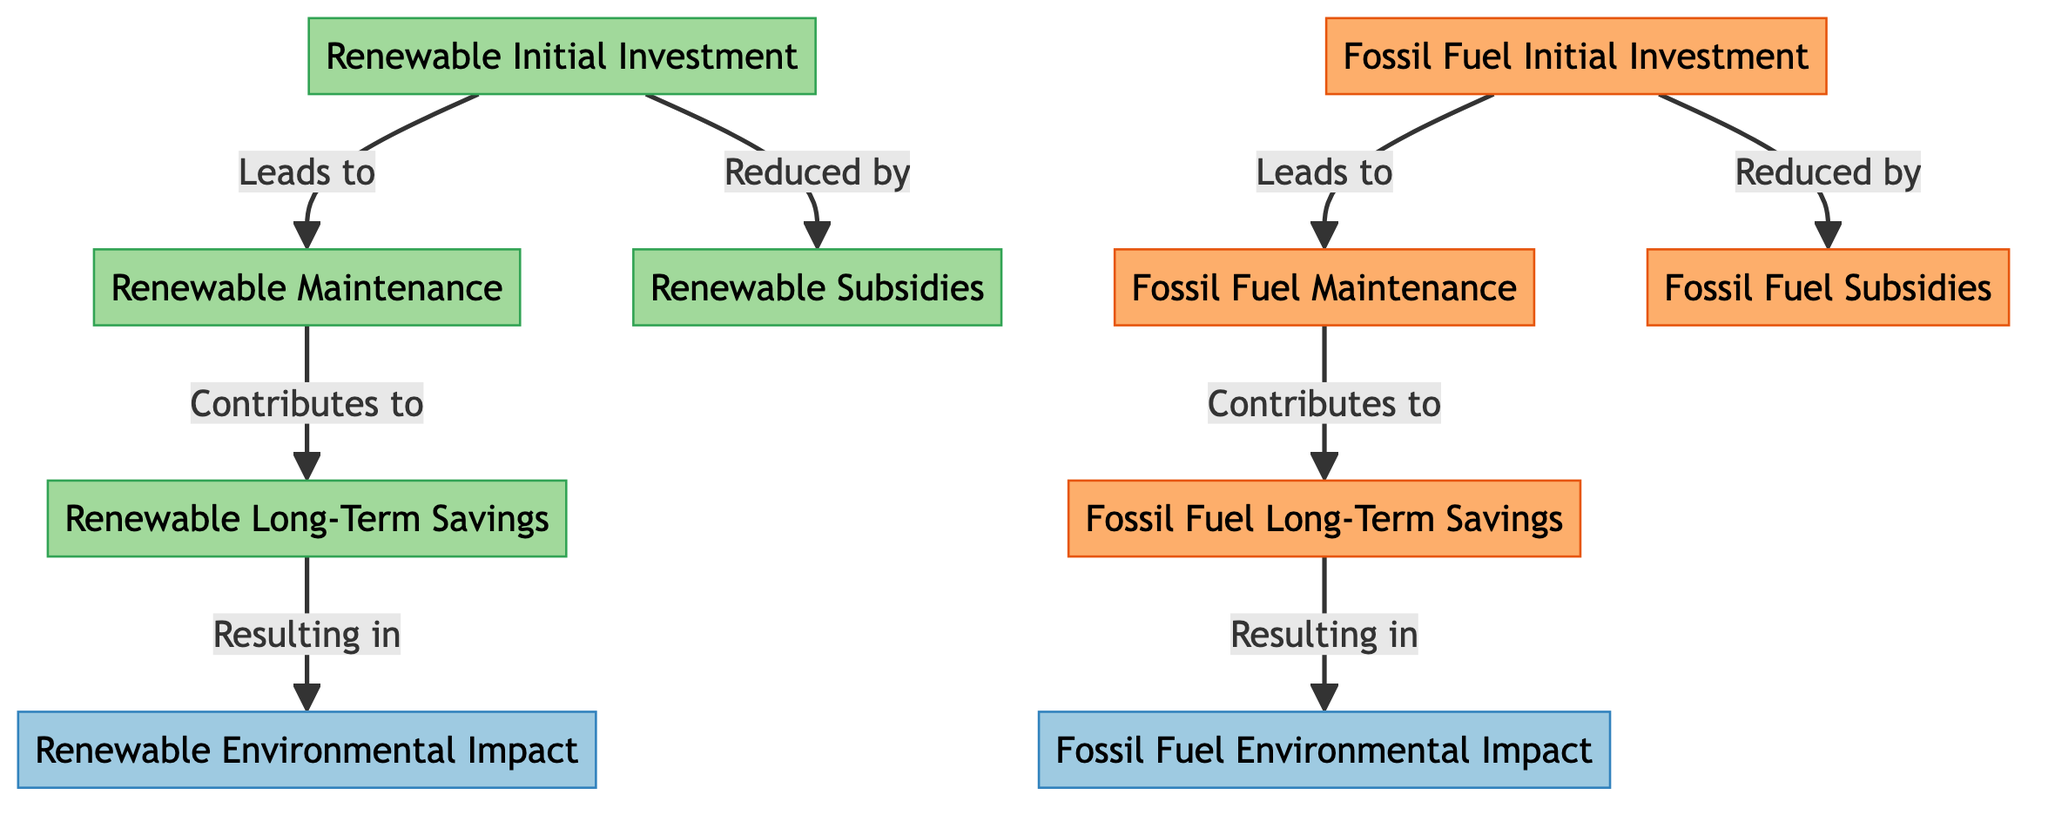What is the flow direction from Renewable Initial Investment? The arrow diverges from the Renewable Initial Investment node leading to both Renewable Maintenance and Renewable Subsidies nodes. This indicates that the initial investment impacts both the maintenance costs and potential subsidies received.
Answer: Renewable Maintenance, Renewable Subsidies How many nodes represent fossil fuel elements in the diagram? There are four nodes that specifically represent fossil fuel elements: Fossil Fuel Initial Investment, Fossil Fuel Maintenance, Fossil Fuel Long-Term Savings, and Fossil Fuel Subsidies.
Answer: Four What is the result of Renewable Long-Term Savings? Renewable Long-Term Savings leads to the Renewable Environmental Impact node, indicating that savings contribute to a positive environmental outcome.
Answer: Renewable Environmental Impact Which node is connected to both Fossil Fuel Initial Investment and Fossil Fuel Maintenance? The diagram indicates a direct connection where Fossil Fuel Initial Investment leads to Fossil Fuel Maintenance, showing the dependency between these two aspects.
Answer: Fossil Fuel Maintenance How do Renewable Subsidies affect Renewable Initial Investment? Renewable Subsidies are directly connected to the Renewable Initial Investment node with an arrow indicating they reduce the initial investment costs, highlighting their importance as financial support.
Answer: Reduced by What is the relationship between Fossil Fuel Long-Term Savings and Fossil Fuel Environmental Impact? Fossil Fuel Long-Term Savings leads into the Fossil Fuel Environmental Impact node, suggesting that the long-term financial benefits contribute to the environmental consequences of fossil fuels.
Answer: Resulting in What type of impact does Renewable Environmental Impact illustrate? This node exemplifies the positive environmental outcomes derived from renewable energy sources, emphasizing sustainability efforts.
Answer: Positive environmental outcomes Is there a connection between Renewable Maintenance and Fossil Maintenance? There is no direct connection between Renewable Maintenance and Fossil Fuel Maintenance in the diagram, as they are classified under different categories of energy sources, indicating separate maintenance paths.
Answer: No connection What overall theme does the diagram depict regarding energy sources? The diagram contrasts renewable energy sources with fossil fuels, showcasing their investment, maintenance, savings, and overall environmental impacts in a comparative structure.
Answer: Economic comparison of energy sources 